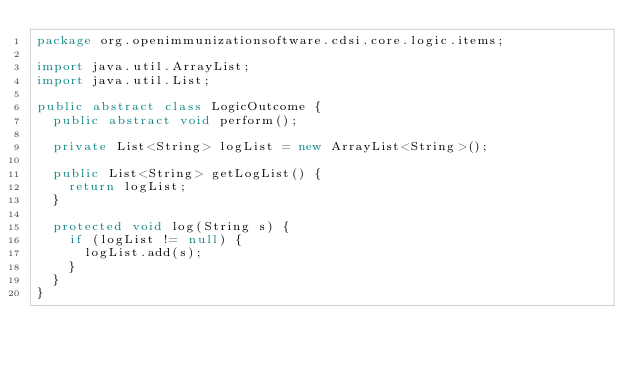<code> <loc_0><loc_0><loc_500><loc_500><_Java_>package org.openimmunizationsoftware.cdsi.core.logic.items;

import java.util.ArrayList;
import java.util.List;

public abstract class LogicOutcome {
  public abstract void perform();

  private List<String> logList = new ArrayList<String>();

  public List<String> getLogList() {
    return logList;
  }

  protected void log(String s) {
    if (logList != null) {
      logList.add(s);
    }
  }
}
</code> 